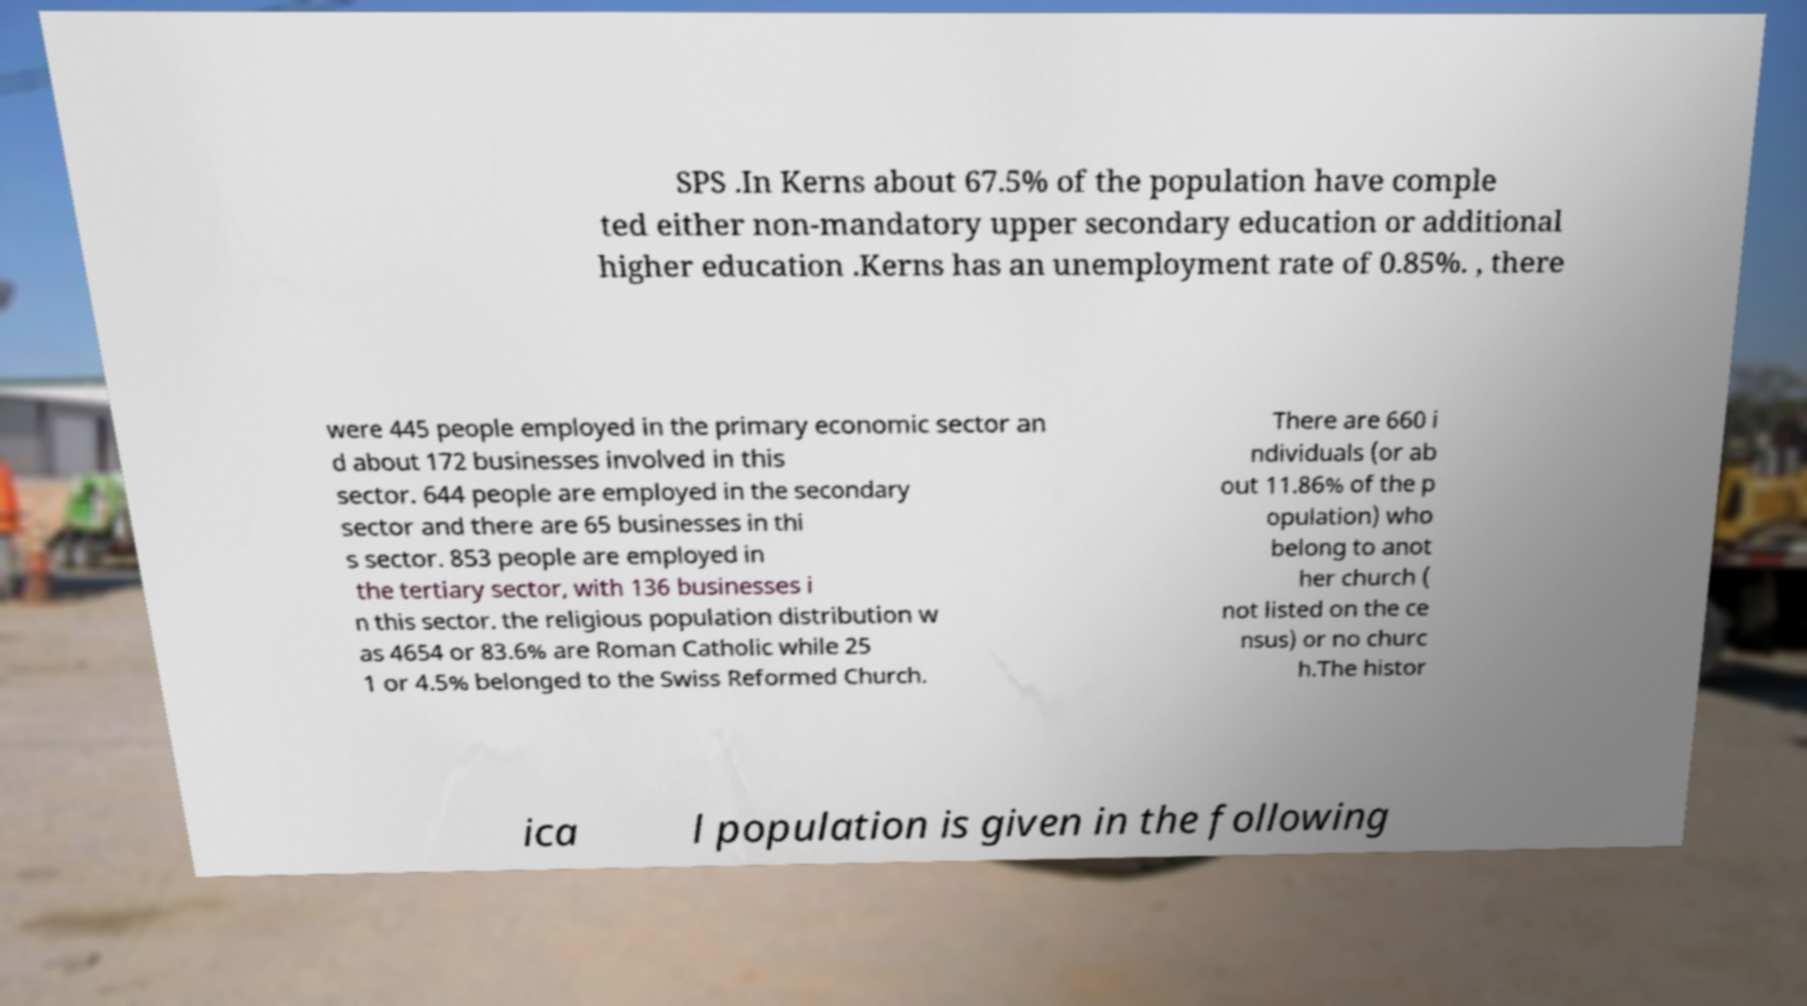For documentation purposes, I need the text within this image transcribed. Could you provide that? SPS .In Kerns about 67.5% of the population have comple ted either non-mandatory upper secondary education or additional higher education .Kerns has an unemployment rate of 0.85%. , there were 445 people employed in the primary economic sector an d about 172 businesses involved in this sector. 644 people are employed in the secondary sector and there are 65 businesses in thi s sector. 853 people are employed in the tertiary sector, with 136 businesses i n this sector. the religious population distribution w as 4654 or 83.6% are Roman Catholic while 25 1 or 4.5% belonged to the Swiss Reformed Church. There are 660 i ndividuals (or ab out 11.86% of the p opulation) who belong to anot her church ( not listed on the ce nsus) or no churc h.The histor ica l population is given in the following 